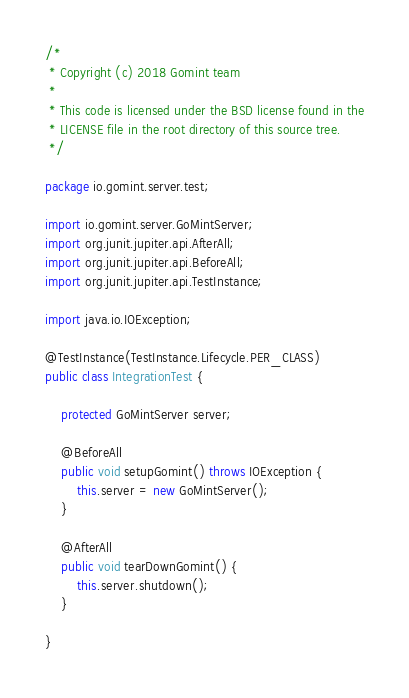<code> <loc_0><loc_0><loc_500><loc_500><_Java_>/*
 * Copyright (c) 2018 Gomint team
 *
 * This code is licensed under the BSD license found in the
 * LICENSE file in the root directory of this source tree.
 */

package io.gomint.server.test;

import io.gomint.server.GoMintServer;
import org.junit.jupiter.api.AfterAll;
import org.junit.jupiter.api.BeforeAll;
import org.junit.jupiter.api.TestInstance;

import java.io.IOException;

@TestInstance(TestInstance.Lifecycle.PER_CLASS)
public class IntegrationTest {

    protected GoMintServer server;

    @BeforeAll
    public void setupGomint() throws IOException {
        this.server = new GoMintServer();
    }
    
    @AfterAll
    public void tearDownGomint() {
        this.server.shutdown();
    }

}
</code> 